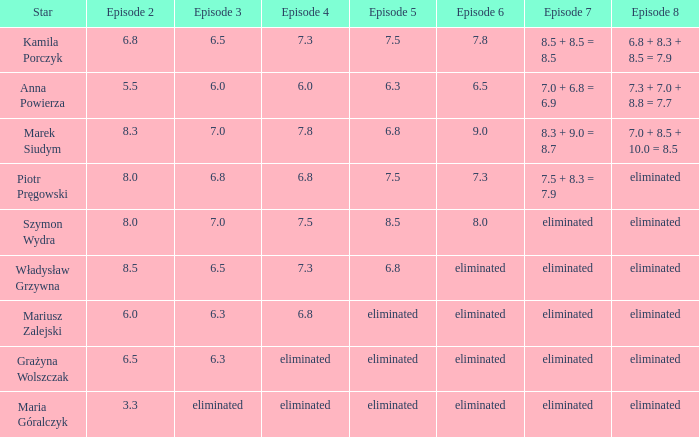In which episode 4 does a star of anna powierza appear? 6.0. 